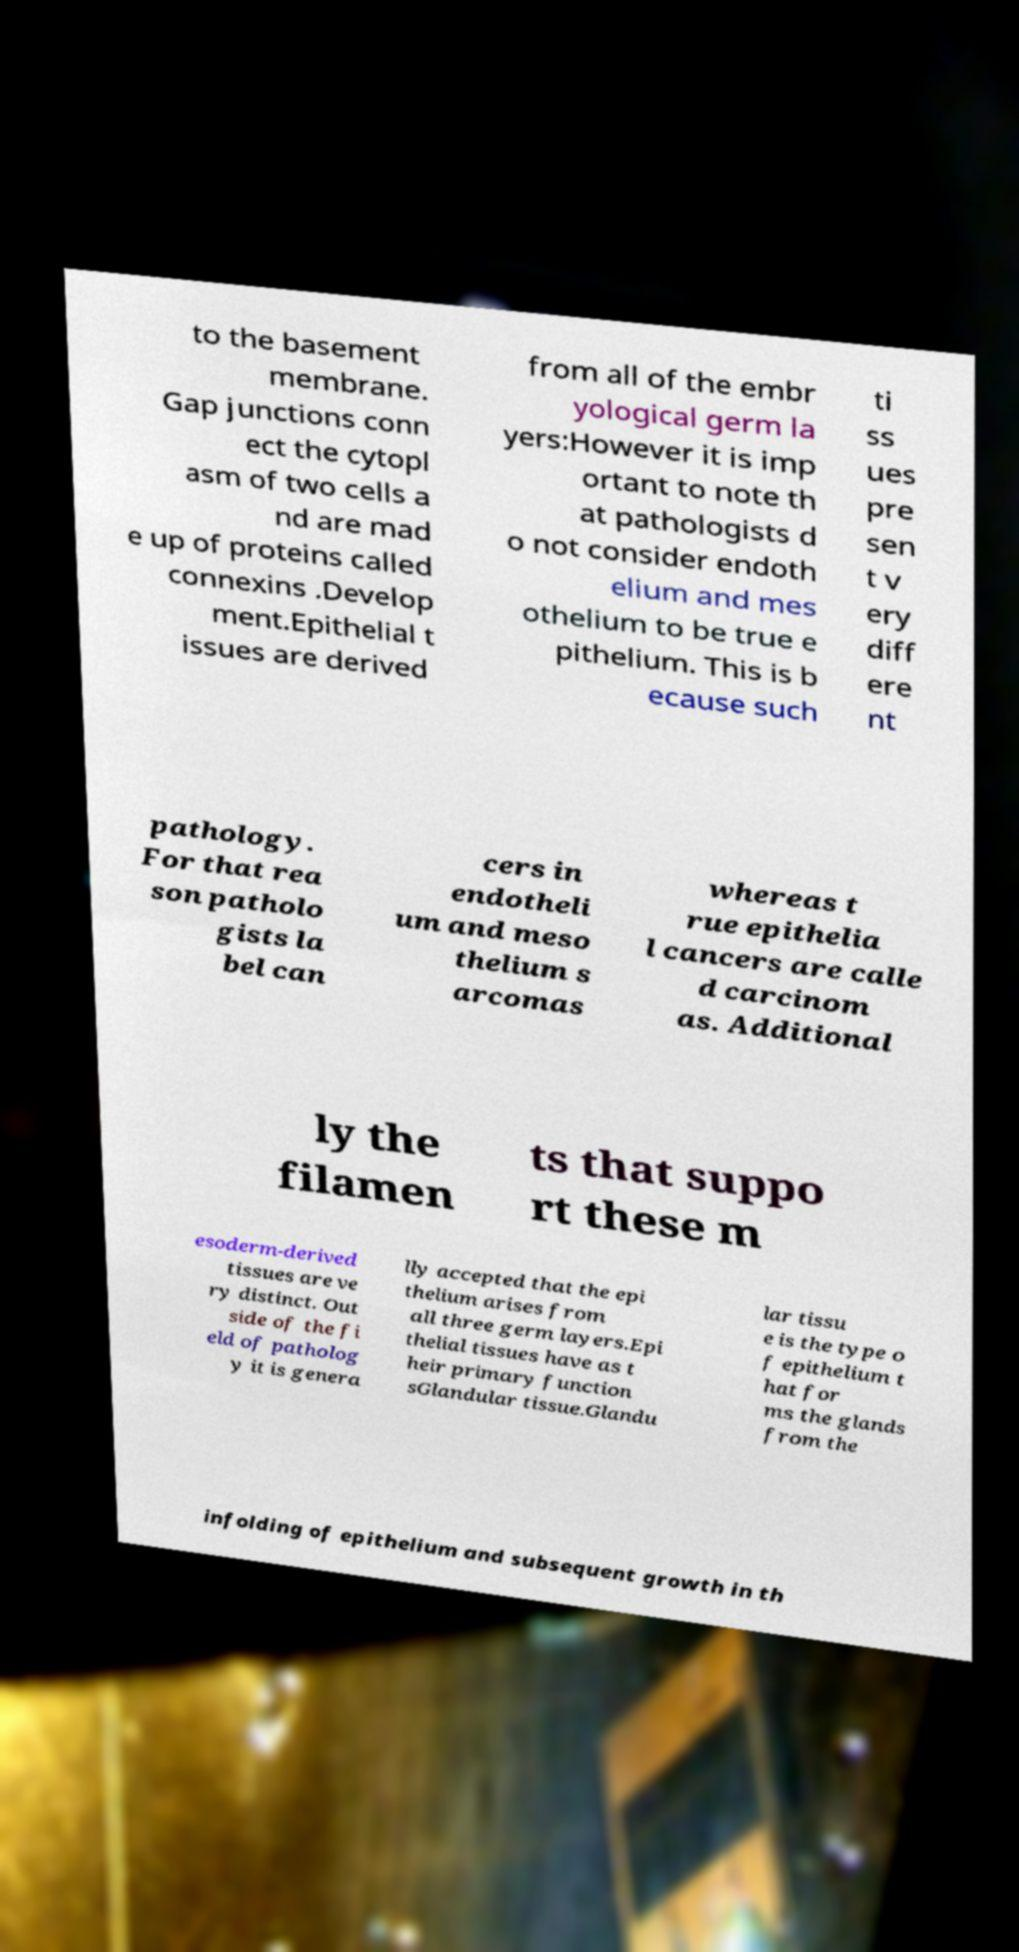Can you read and provide the text displayed in the image?This photo seems to have some interesting text. Can you extract and type it out for me? to the basement membrane. Gap junctions conn ect the cytopl asm of two cells a nd are mad e up of proteins called connexins .Develop ment.Epithelial t issues are derived from all of the embr yological germ la yers:However it is imp ortant to note th at pathologists d o not consider endoth elium and mes othelium to be true e pithelium. This is b ecause such ti ss ues pre sen t v ery diff ere nt pathology. For that rea son patholo gists la bel can cers in endotheli um and meso thelium s arcomas whereas t rue epithelia l cancers are calle d carcinom as. Additional ly the filamen ts that suppo rt these m esoderm-derived tissues are ve ry distinct. Out side of the fi eld of patholog y it is genera lly accepted that the epi thelium arises from all three germ layers.Epi thelial tissues have as t heir primary function sGlandular tissue.Glandu lar tissu e is the type o f epithelium t hat for ms the glands from the infolding of epithelium and subsequent growth in th 